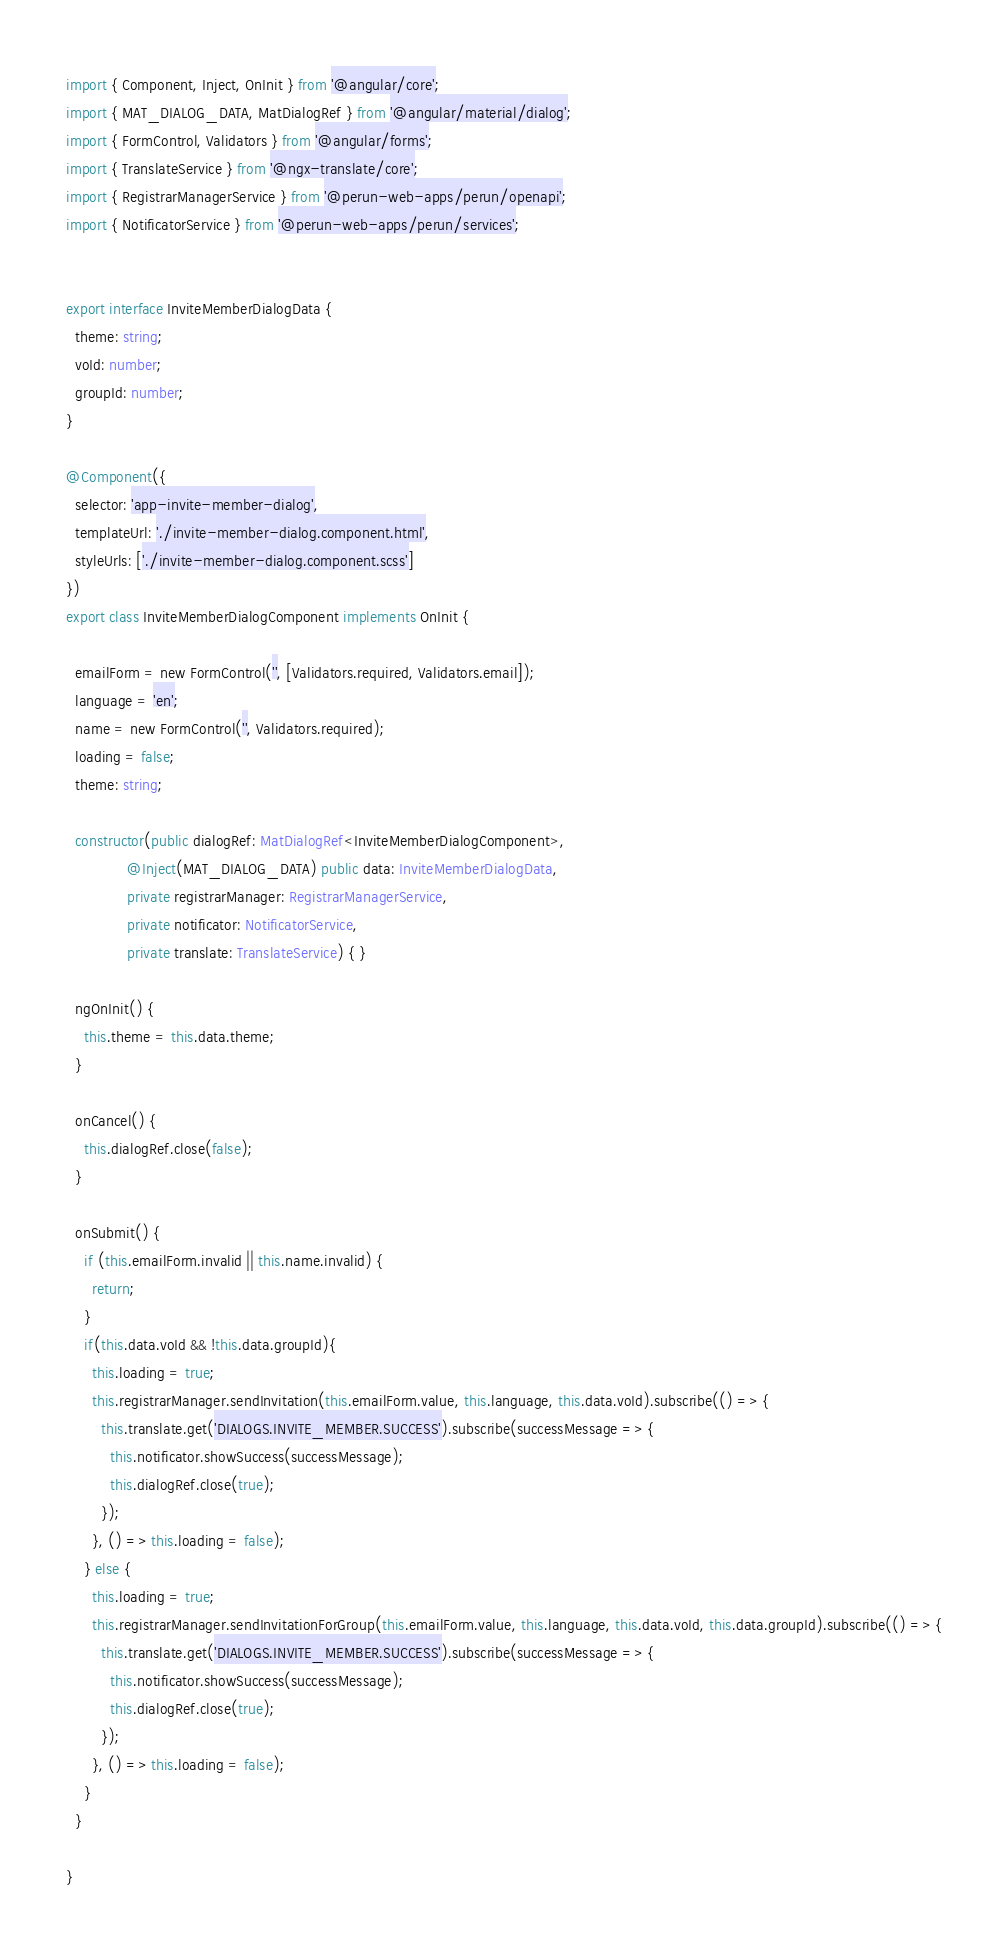Convert code to text. <code><loc_0><loc_0><loc_500><loc_500><_TypeScript_>import { Component, Inject, OnInit } from '@angular/core';
import { MAT_DIALOG_DATA, MatDialogRef } from '@angular/material/dialog';
import { FormControl, Validators } from '@angular/forms';
import { TranslateService } from '@ngx-translate/core';
import { RegistrarManagerService } from '@perun-web-apps/perun/openapi';
import { NotificatorService } from '@perun-web-apps/perun/services';


export interface InviteMemberDialogData {
  theme: string;
  voId: number;
  groupId: number;
}

@Component({
  selector: 'app-invite-member-dialog',
  templateUrl: './invite-member-dialog.component.html',
  styleUrls: ['./invite-member-dialog.component.scss']
})
export class InviteMemberDialogComponent implements OnInit {

  emailForm = new FormControl('', [Validators.required, Validators.email]);
  language = 'en';
  name = new FormControl('', Validators.required);
  loading = false;
  theme: string;

  constructor(public dialogRef: MatDialogRef<InviteMemberDialogComponent>,
              @Inject(MAT_DIALOG_DATA) public data: InviteMemberDialogData,
              private registrarManager: RegistrarManagerService,
              private notificator: NotificatorService,
              private translate: TranslateService) { }

  ngOnInit() {
    this.theme = this.data.theme;
  }

  onCancel() {
    this.dialogRef.close(false);
  }

  onSubmit() {
    if (this.emailForm.invalid || this.name.invalid) {
      return;
    }
    if(this.data.voId && !this.data.groupId){
      this.loading = true;
      this.registrarManager.sendInvitation(this.emailForm.value, this.language, this.data.voId).subscribe(() => {
        this.translate.get('DIALOGS.INVITE_MEMBER.SUCCESS').subscribe(successMessage => {
          this.notificator.showSuccess(successMessage);
          this.dialogRef.close(true);
        });
      }, () => this.loading = false);
    } else {
      this.loading = true;
      this.registrarManager.sendInvitationForGroup(this.emailForm.value, this.language, this.data.voId, this.data.groupId).subscribe(() => {
        this.translate.get('DIALOGS.INVITE_MEMBER.SUCCESS').subscribe(successMessage => {
          this.notificator.showSuccess(successMessage);
          this.dialogRef.close(true);
        });
      }, () => this.loading = false);
    }
  }

}
</code> 